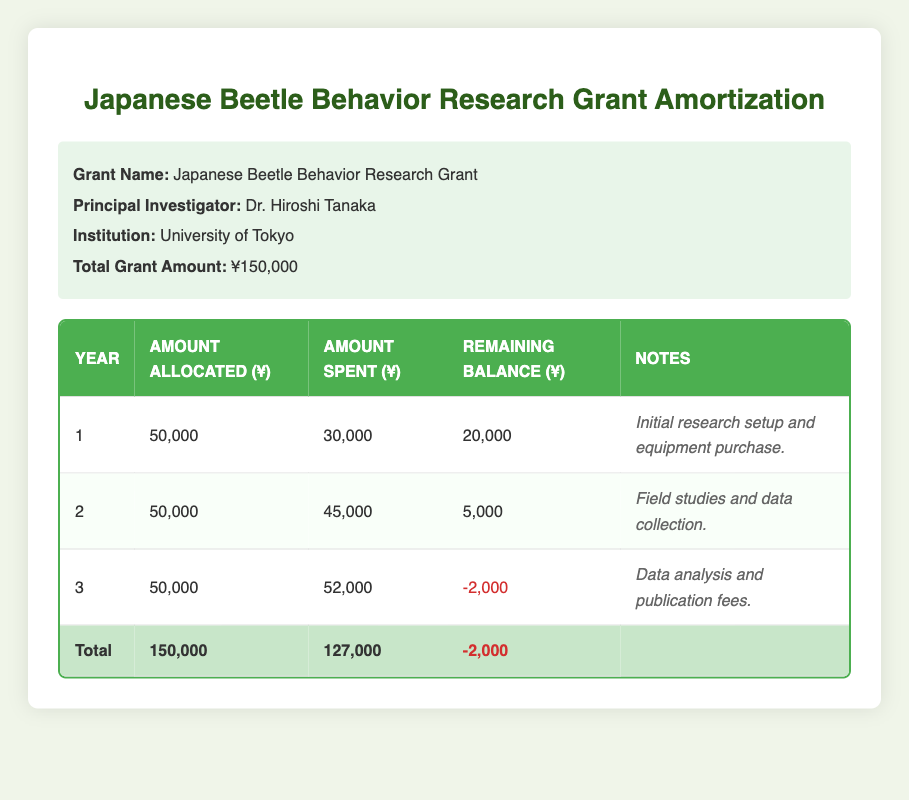What is the total amount allocated over the three years? The total amount allocated can be found by adding the amounts allocated for each year: 50,000 (year 1) + 50,000 (year 2) + 50,000 (year 3) = 150,000.
Answer: 150,000 How much was spent in the second year? To find the amount spent in the second year, we can look directly at the row for year 2, which shows an amount spent of 45,000.
Answer: 45,000 Is the remaining balance after year 3 positive? The remaining balance after year 3 is listed as -2,000, which indicates it is negative. Therefore, the answer to the question is no.
Answer: No What is the total amount spent across all three years? To calculate the total amount spent, we add the amounts spent for each year: 30,000 (year 1) + 45,000 (year 2) + 52,000 (year 3) = 127,000.
Answer: 127,000 Was the amount allocated in year 1 fully utilized? The amount allocated in year 1 was 50,000, and the amount spent was 30,000. Since not all of the allocated amount was spent, the answer is no.
Answer: No By how much did the spending exceed the allocation in year 3? In year 3, the amount allocated was 50,000 and the amount spent was 52,000. To find how much the spending exceeded the allocation, subtract the allocated amount from the spent amount: 52,000 - 50,000 = 2,000.
Answer: 2,000 What was the remaining balance at the end of year 2? The remaining balance at the end of year 2 is noted in the table, which shows 5,000.
Answer: 5,000 What is the total remaining balance after all three years? The total remaining balance at the end after three years is listed as -2,000. This value represents the overall financial position at the end of the amortization period.
Answer: -2,000 How much was the initial research setup cost compared to the field studies and data collection in year 2? The amount spent in year 1 for the initial research setup was 30,000, while the amount spent in year 2 for field studies and data collection was 45,000. To see how they compare, we can see that 30,000 is less than 45,000, so the initial cost was lower.
Answer: Lower 